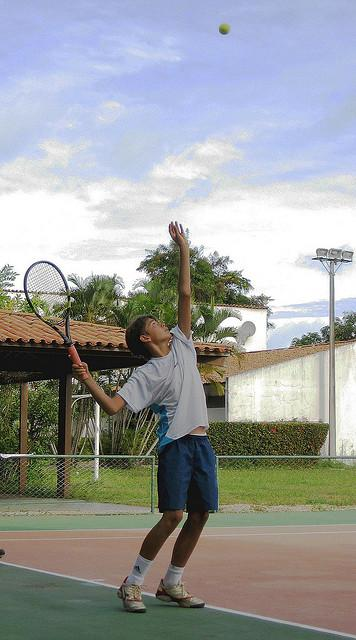Why is he standing like that? Please explain your reasoning. ball coming. The person is waiting for something to fall to him so he can hit it with a racquet. option a matches the item and its action. 